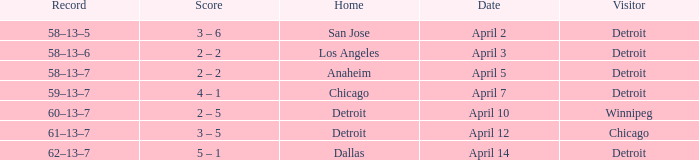Who was the home team in the game having a visitor of Chicago? Detroit. 